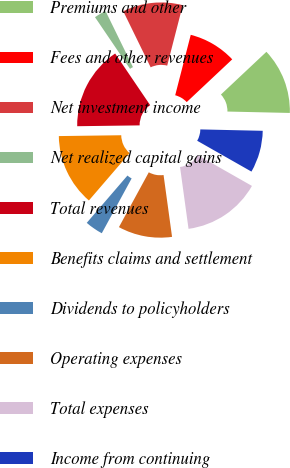Convert chart. <chart><loc_0><loc_0><loc_500><loc_500><pie_chart><fcel>Premiums and other<fcel>Fees and other revenues<fcel>Net investment income<fcel>Net realized capital gains<fcel>Total revenues<fcel>Benefits claims and settlement<fcel>Dividends to policyholders<fcel>Operating expenses<fcel>Total expenses<fcel>Income from continuing<nl><fcel>12.36%<fcel>8.99%<fcel>11.24%<fcel>2.25%<fcel>15.73%<fcel>13.48%<fcel>3.37%<fcel>10.11%<fcel>14.6%<fcel>7.87%<nl></chart> 